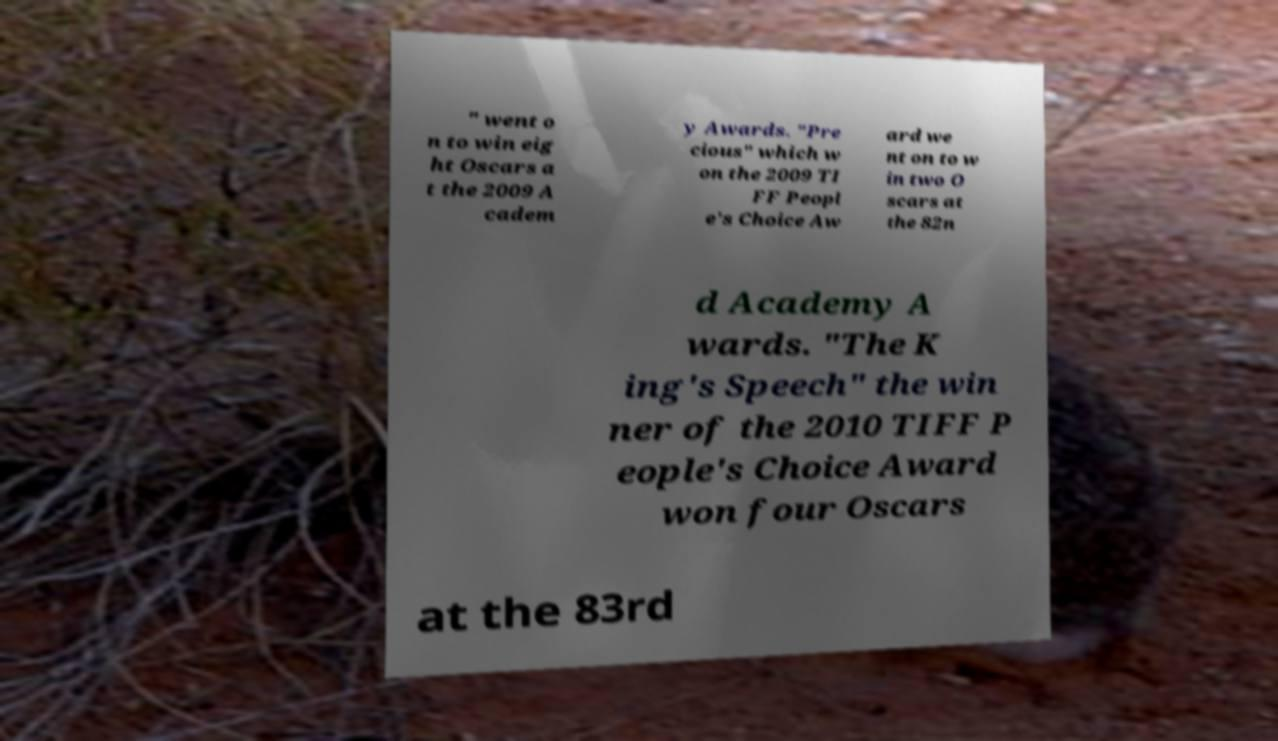I need the written content from this picture converted into text. Can you do that? " went o n to win eig ht Oscars a t the 2009 A cadem y Awards. "Pre cious" which w on the 2009 TI FF Peopl e's Choice Aw ard we nt on to w in two O scars at the 82n d Academy A wards. "The K ing's Speech" the win ner of the 2010 TIFF P eople's Choice Award won four Oscars at the 83rd 